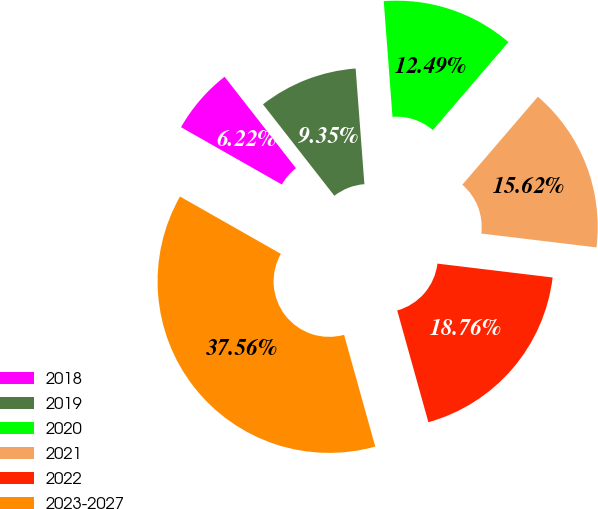Convert chart. <chart><loc_0><loc_0><loc_500><loc_500><pie_chart><fcel>2018<fcel>2019<fcel>2020<fcel>2021<fcel>2022<fcel>2023-2027<nl><fcel>6.22%<fcel>9.35%<fcel>12.49%<fcel>15.62%<fcel>18.76%<fcel>37.56%<nl></chart> 